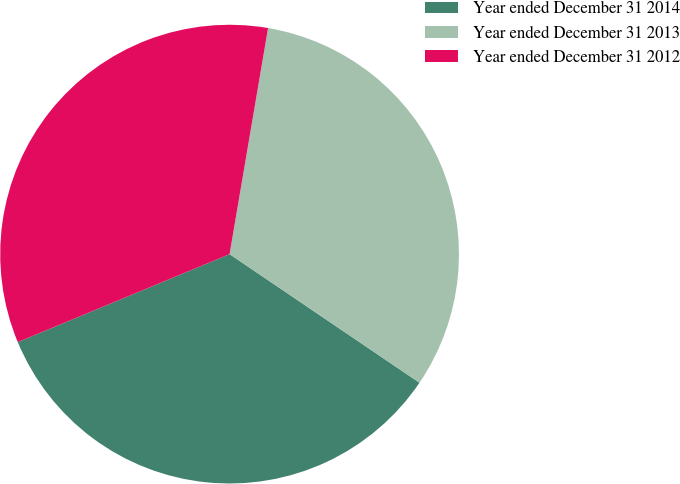Convert chart. <chart><loc_0><loc_0><loc_500><loc_500><pie_chart><fcel>Year ended December 31 2014<fcel>Year ended December 31 2013<fcel>Year ended December 31 2012<nl><fcel>34.26%<fcel>31.79%<fcel>33.95%<nl></chart> 